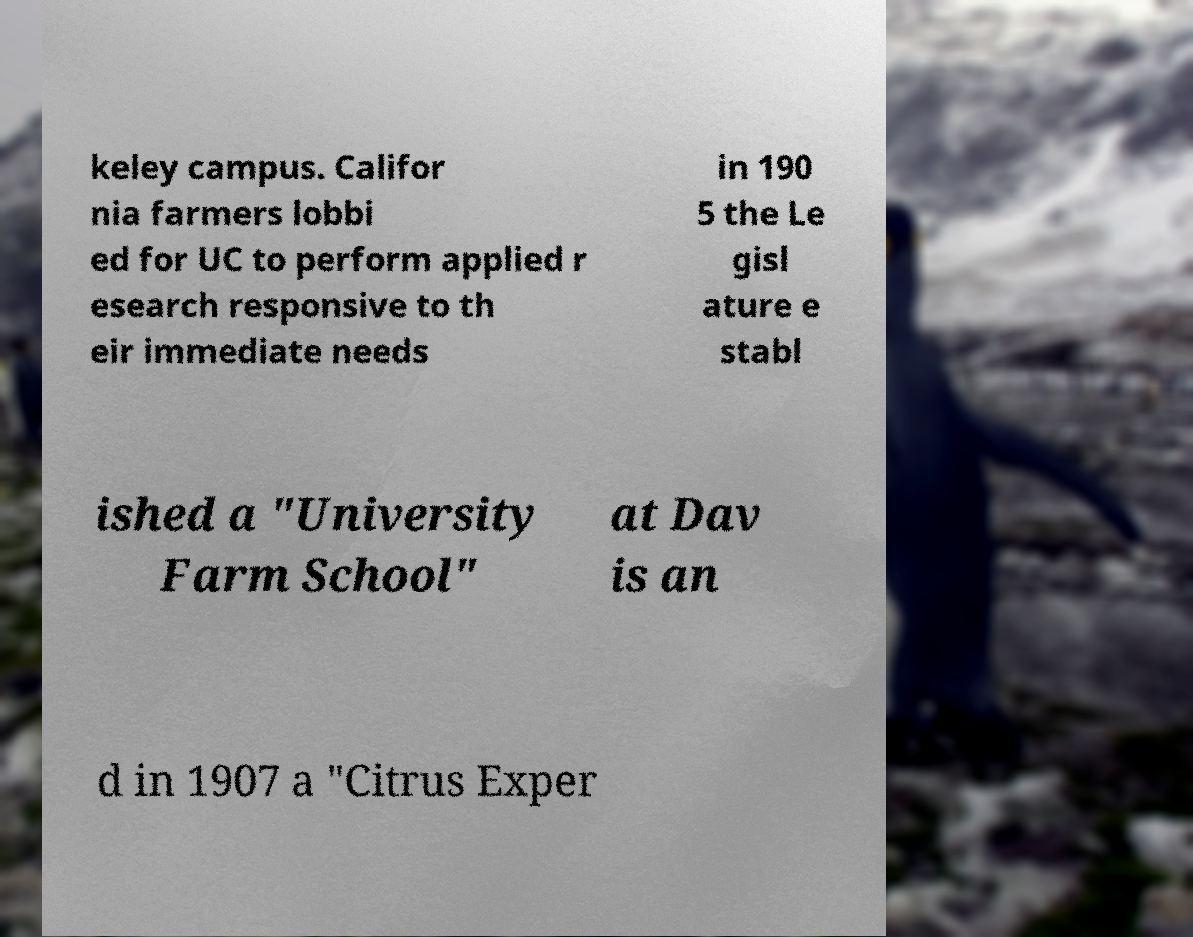For documentation purposes, I need the text within this image transcribed. Could you provide that? keley campus. Califor nia farmers lobbi ed for UC to perform applied r esearch responsive to th eir immediate needs in 190 5 the Le gisl ature e stabl ished a "University Farm School" at Dav is an d in 1907 a "Citrus Exper 